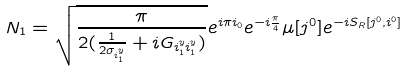<formula> <loc_0><loc_0><loc_500><loc_500>N _ { 1 } = \sqrt { \frac { \pi } { 2 ( \frac { 1 } { 2 \sigma _ { i ^ { y } _ { 1 } } } + i G _ { i ^ { y } _ { 1 } i ^ { y } _ { 1 } } ) } } e ^ { i \pi i _ { 0 } } e ^ { - i \frac { \pi } { 4 } } \mu [ j ^ { 0 } ] e ^ { - i S _ { R } [ j ^ { 0 } , i ^ { 0 } ] }</formula> 